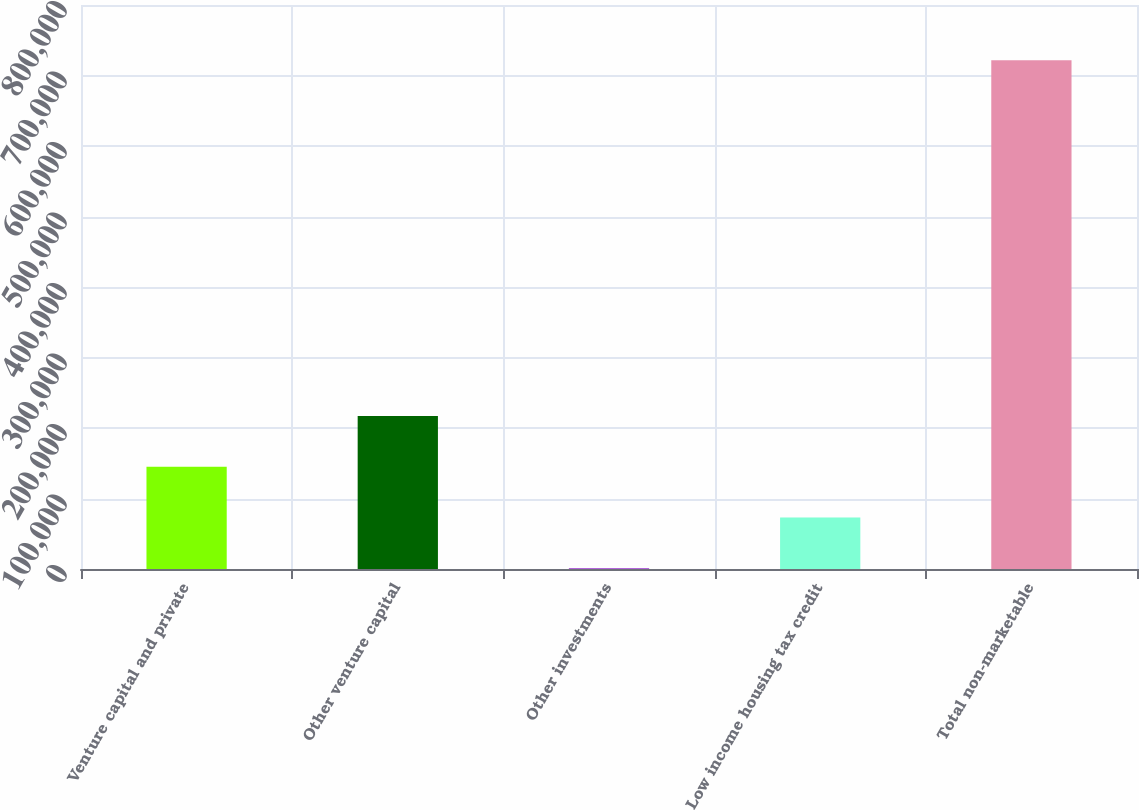Convert chart. <chart><loc_0><loc_0><loc_500><loc_500><bar_chart><fcel>Venture capital and private<fcel>Other venture capital<fcel>Other investments<fcel>Low income housing tax credit<fcel>Total non-marketable<nl><fcel>145089<fcel>217143<fcel>981<fcel>73034.9<fcel>721520<nl></chart> 